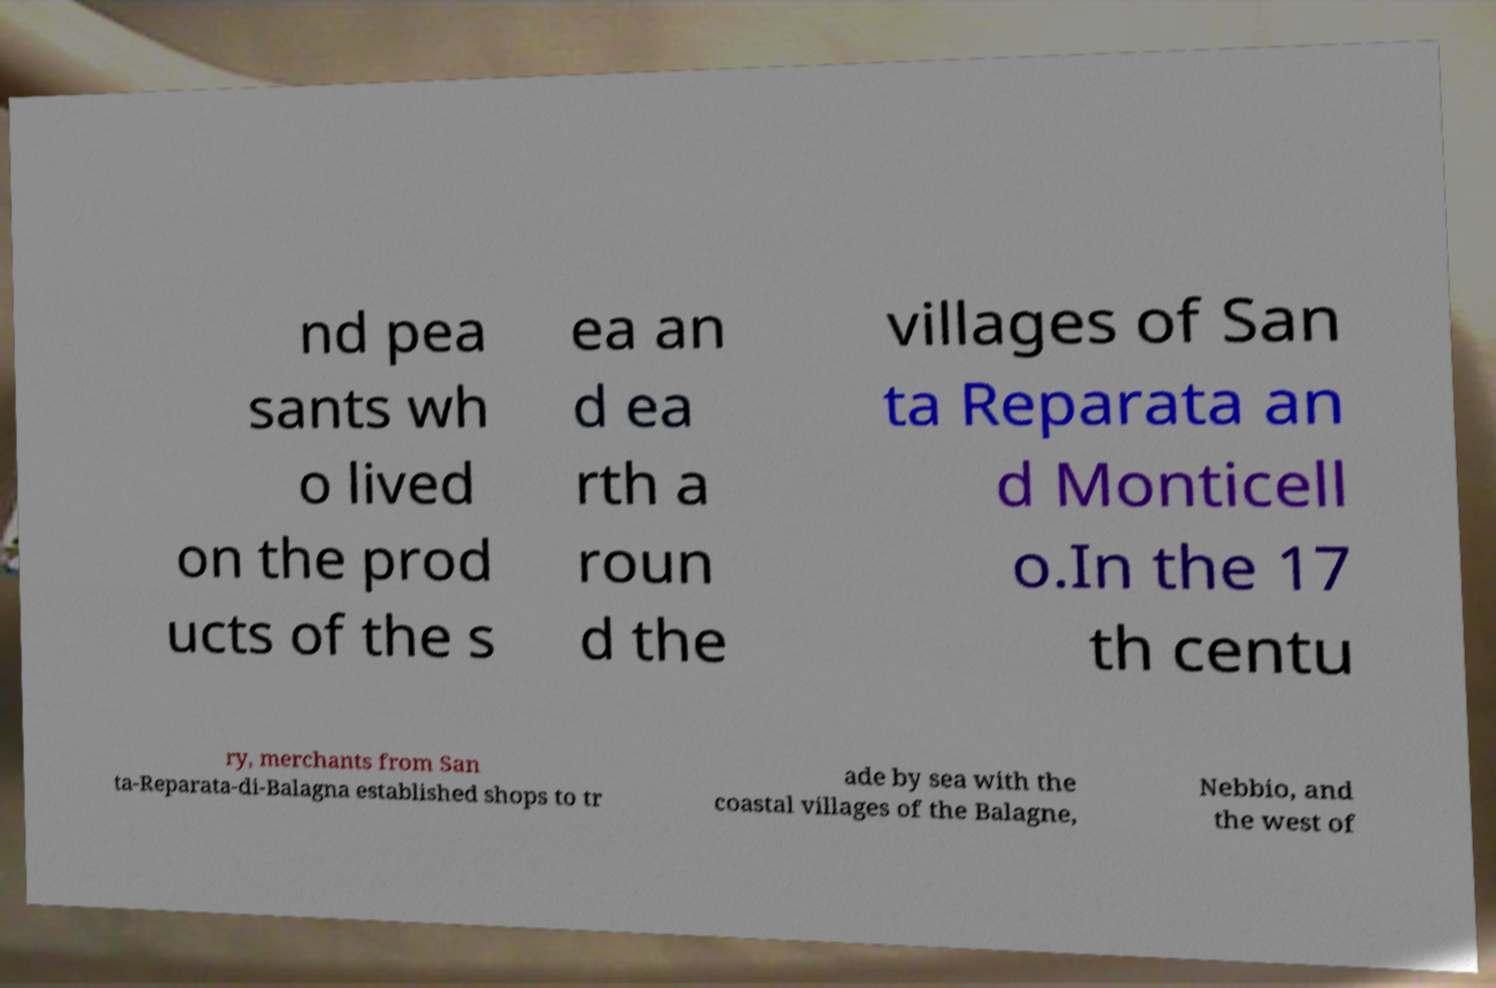What messages or text are displayed in this image? I need them in a readable, typed format. nd pea sants wh o lived on the prod ucts of the s ea an d ea rth a roun d the villages of San ta Reparata an d Monticell o.In the 17 th centu ry, merchants from San ta-Reparata-di-Balagna established shops to tr ade by sea with the coastal villages of the Balagne, Nebbio, and the west of 